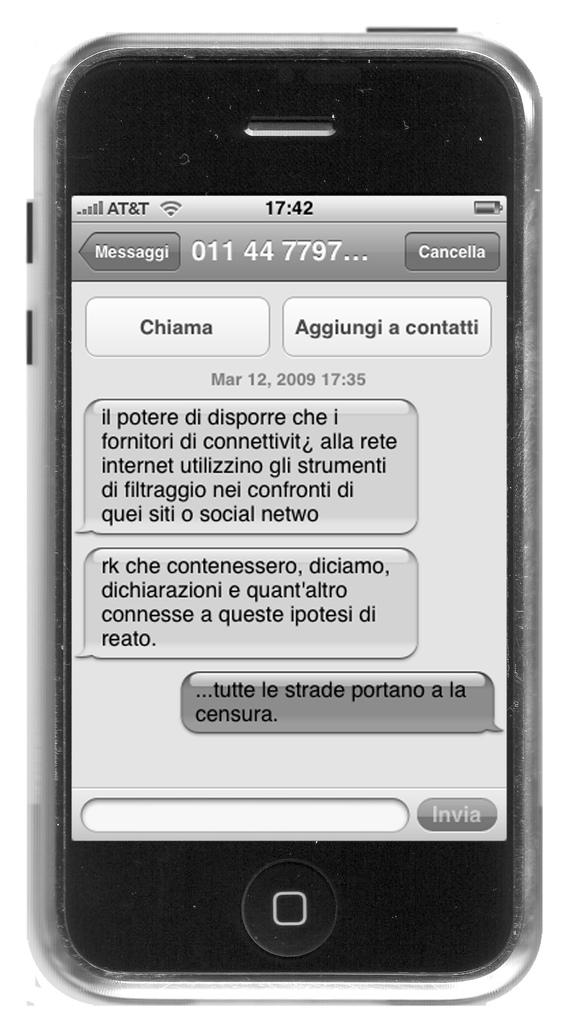<image>
Write a terse but informative summary of the picture. An iPhone screen displaying a conversation shows the time of 17:42. 